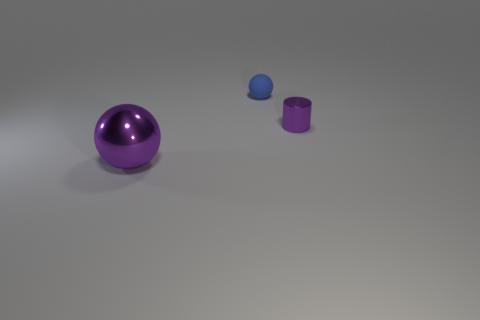What materials do the objects in this image seem to be made of? The objects appear to be rendered with materials imitating metal, exhibiting smooth surfaces and reflective properties that suggest a metallic composition. 